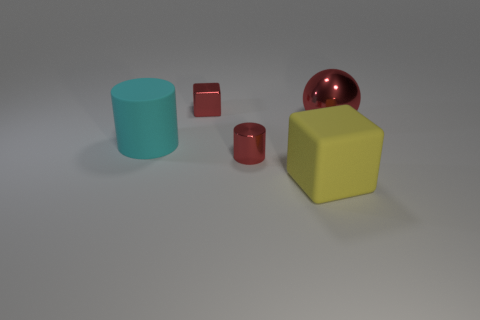Add 3 large cylinders. How many objects exist? 8 Subtract all cylinders. How many objects are left? 3 Add 4 tiny red metallic cubes. How many tiny red metallic cubes are left? 5 Add 1 gray metallic spheres. How many gray metallic spheres exist? 1 Subtract 1 cyan cylinders. How many objects are left? 4 Subtract all red metal things. Subtract all cubes. How many objects are left? 0 